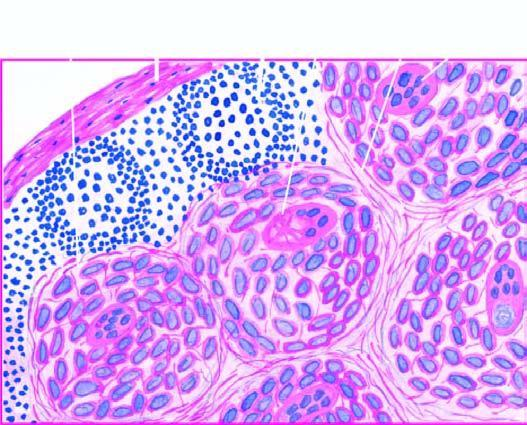what are there have paucity of lymphocytes?
Answer the question using a single word or phrase. Non-caseating epithelioid cell granulomas 